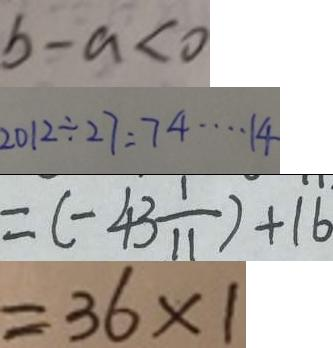Convert formula to latex. <formula><loc_0><loc_0><loc_500><loc_500>b - a < 0 
 2 0 1 2 \div 2 7 = 7 4 \cdots 1 4 
 = ( - 4 3 \frac { 1 } { 1 1 } ) + 1 6 
 = 3 6 \times 1</formula> 